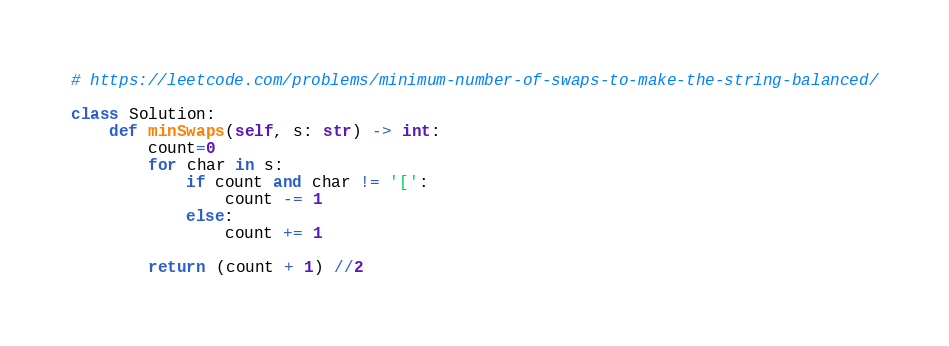<code> <loc_0><loc_0><loc_500><loc_500><_Python_># https://leetcode.com/problems/minimum-number-of-swaps-to-make-the-string-balanced/

class Solution:
    def minSwaps(self, s: str) -> int:
        count=0
        for char in s:
            if count and char != '[':
                count -= 1
            else:
                count += 1
                
        return (count + 1) //2
</code> 